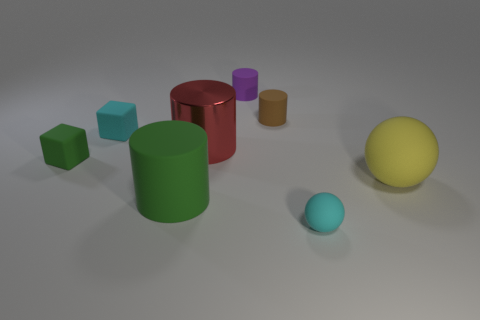Subtract 1 cylinders. How many cylinders are left? 3 Add 1 tiny metallic balls. How many objects exist? 9 Subtract all balls. How many objects are left? 6 Subtract 1 green cylinders. How many objects are left? 7 Subtract all cyan cubes. Subtract all big green cylinders. How many objects are left? 6 Add 3 red metallic things. How many red metallic things are left? 4 Add 1 small red metal objects. How many small red metal objects exist? 1 